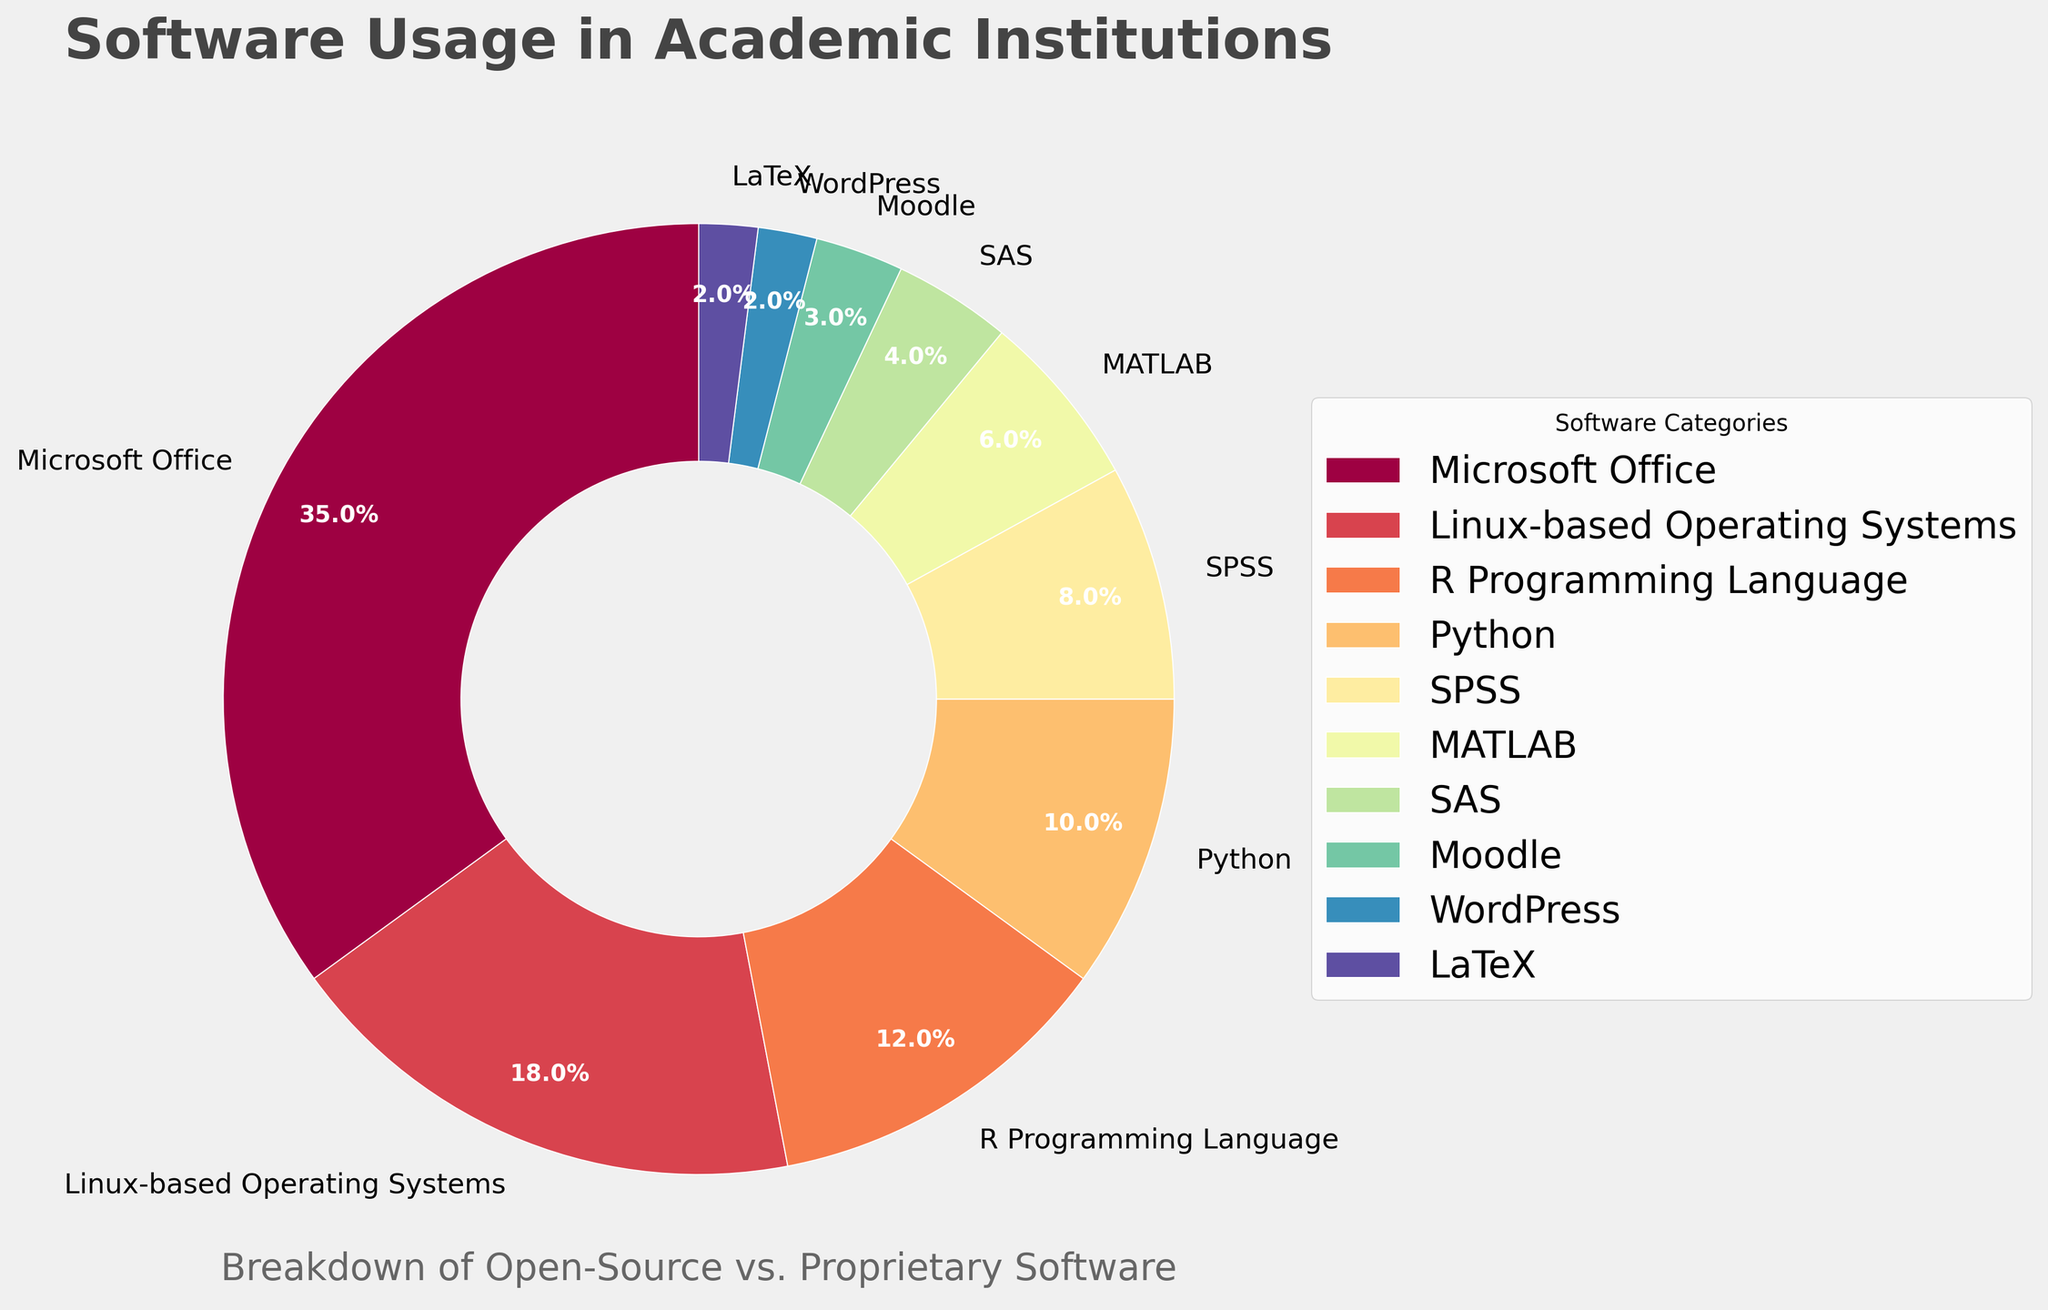What percentage of the software usage is open-source? To find the total percentage of open-source software, sum the percentages for Linux-based Operating Systems, R Programming Language, Python, Moodle, WordPress, and LaTeX: 18% + 12% + 10% + 3% + 2% + 2% = 47%
Answer: 47% Between Microsoft Office and Linux-based Operating Systems, which one has a larger usage percentage, and by how much? Compare the percentages: Microsoft Office (35%) and Linux-based Operating Systems (18%). The difference is 35% - 18% = 17%
Answer: Microsoft Office by 17% What is the combined percentage of SPSS and SAS usage? Sum the percentages of SPSS and SAS: 8% + 4% = 12%
Answer: 12% Which proprietary software has the lowest usage percentage? From the data, the proprietary software categories are Microsoft Office, SPSS, MATLAB, and SAS. The percentages are 35%, 8%, 6%, and 4% respectively. SAS has the lowest percentage at 4%
Answer: SAS What percentage of software usage is from statistical tools (SPSS, MATLAB, and SAS)? Sum the percentages of SPSS, MATLAB, and SAS: 8% + 6% + 4% = 18%
Answer: 18% How does the usage of Python compare to that of MATLAB? Compare the percentages: Python (10%) and MATLAB (6%). Python is used more: 10% - 6% = 4%
Answer: Python more by 4% How much more is the usage of Microsoft Office than all Linux-based Operating Systems and Python combined? First, sum the usage of Linux-based Operating Systems and Python: 18% + 10% = 28%. Then, compare this to Microsoft Office (35%): 35% - 28% = 7%
Answer: 7% If we were to group WordPress and LaTeX together, what would be their combined percentage? Sum the usages of WordPress and LaTeX: 2% + 2% = 4%
Answer: 4% Which software category has the highest percentage, and what is it? The highest percentage is Microsoft Office at 35%
Answer: Microsoft Office, 35% Is Moodle usage greater than that of WordPress and LaTeX combined? Compare the percentages: Moodle (3%) and WordPress + LaTeX (2% + 2% = 4%). Moodle is not greater than the combined WordPress and LaTeX
Answer: No, it is less 